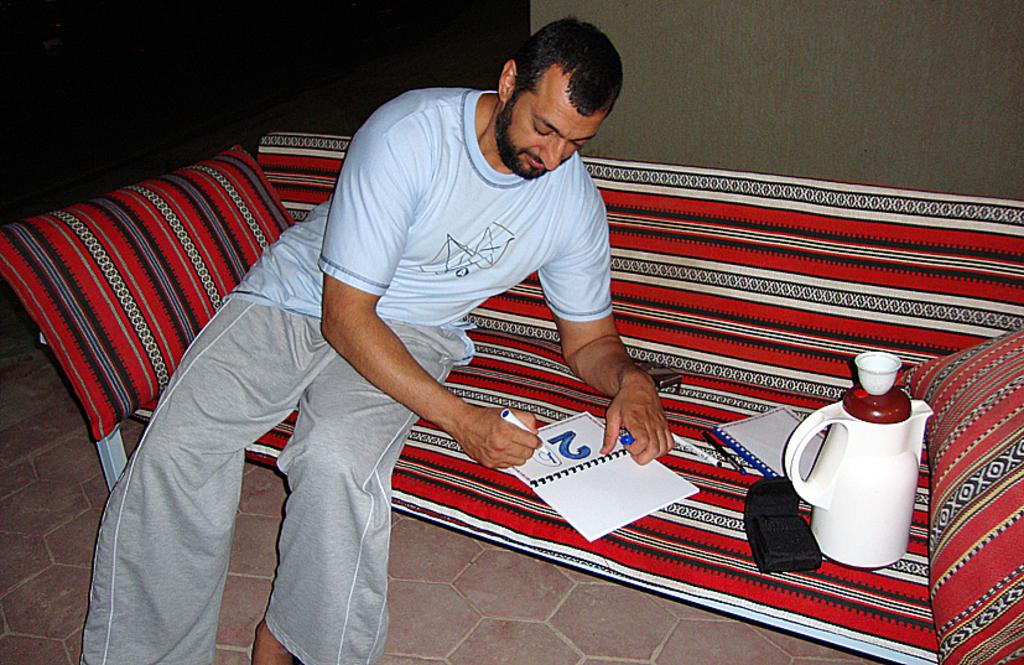<image>
Provide a brief description of the given image. A man colors in the number 20 while sitting on a couch. 